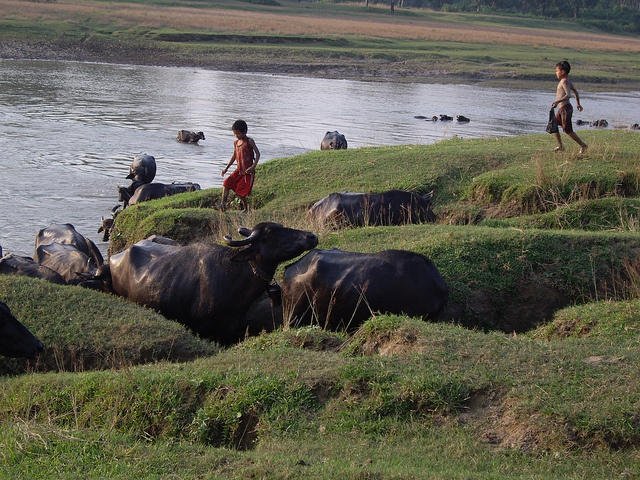Describe the objects in this image and their specific colors. I can see cow in gray and black tones, cow in gray and black tones, cow in gray and black tones, people in gray, maroon, black, and brown tones, and cow in gray, black, darkgray, and tan tones in this image. 